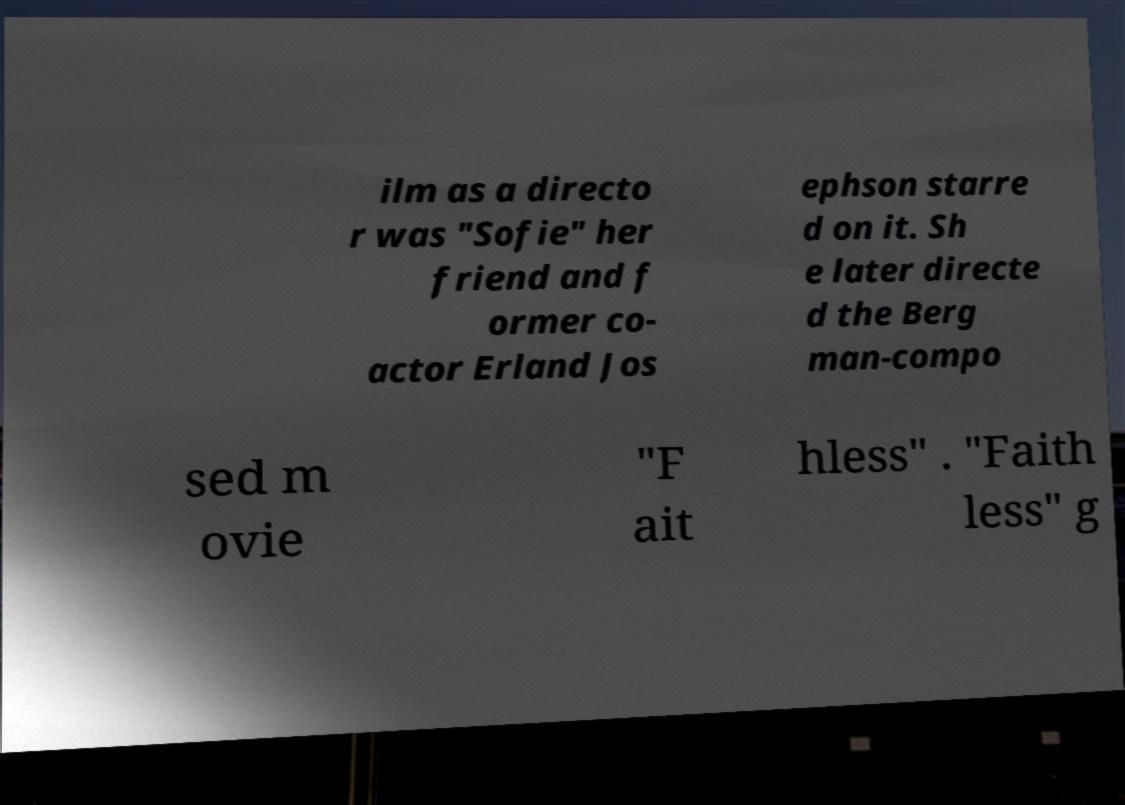Please read and relay the text visible in this image. What does it say? ilm as a directo r was "Sofie" her friend and f ormer co- actor Erland Jos ephson starre d on it. Sh e later directe d the Berg man-compo sed m ovie "F ait hless" . "Faith less" g 